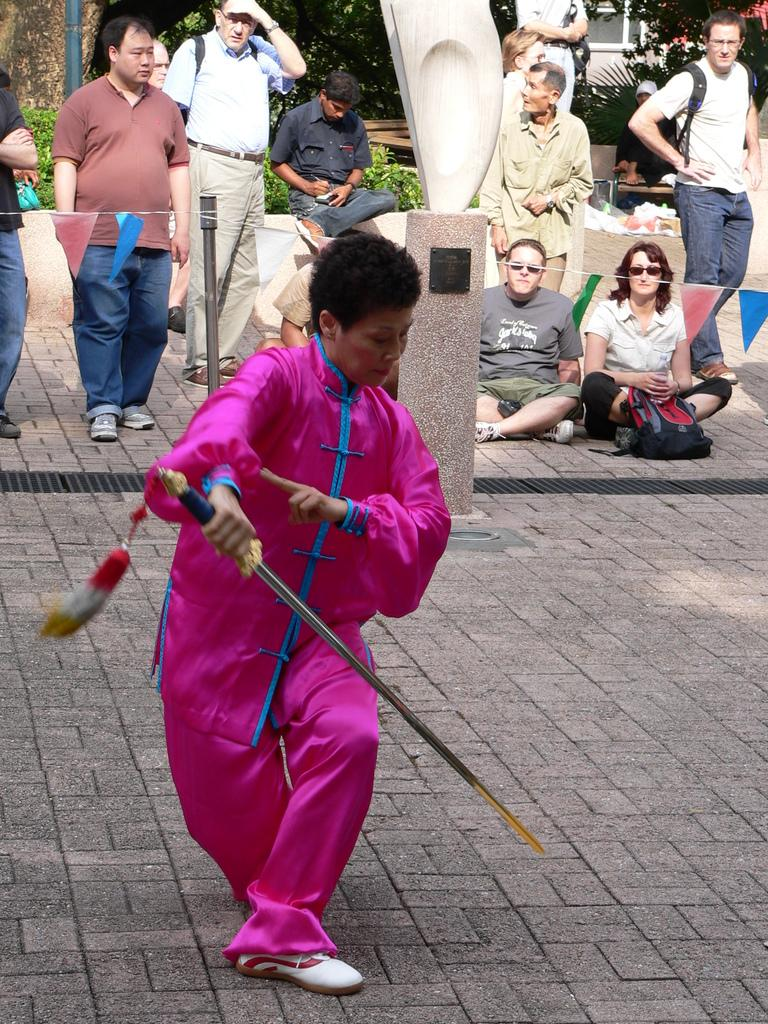What is the person in the image holding? The person in the image is holding a sword. What is the person wearing? The person is wearing a pink dress. Are there any other people present in the image? Yes, there are other people observing the action in the image. What type of bed can be seen in the image? There is no bed present in the image. What kind of wood is used to make the sword in the image? The image does not provide information about the material used to make the sword. 